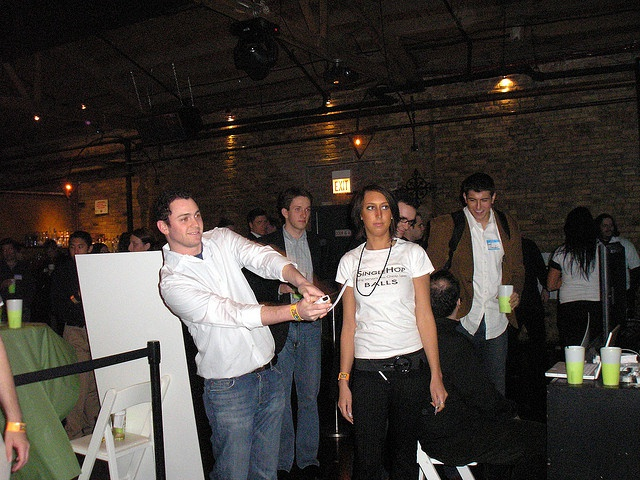Describe the objects in this image and their specific colors. I can see people in black, lightgray, gray, and lightpink tones, people in black, lightgray, and salmon tones, people in black, maroon, and gray tones, people in black, maroon, darkgray, and lightgray tones, and people in black, blue, and gray tones in this image. 